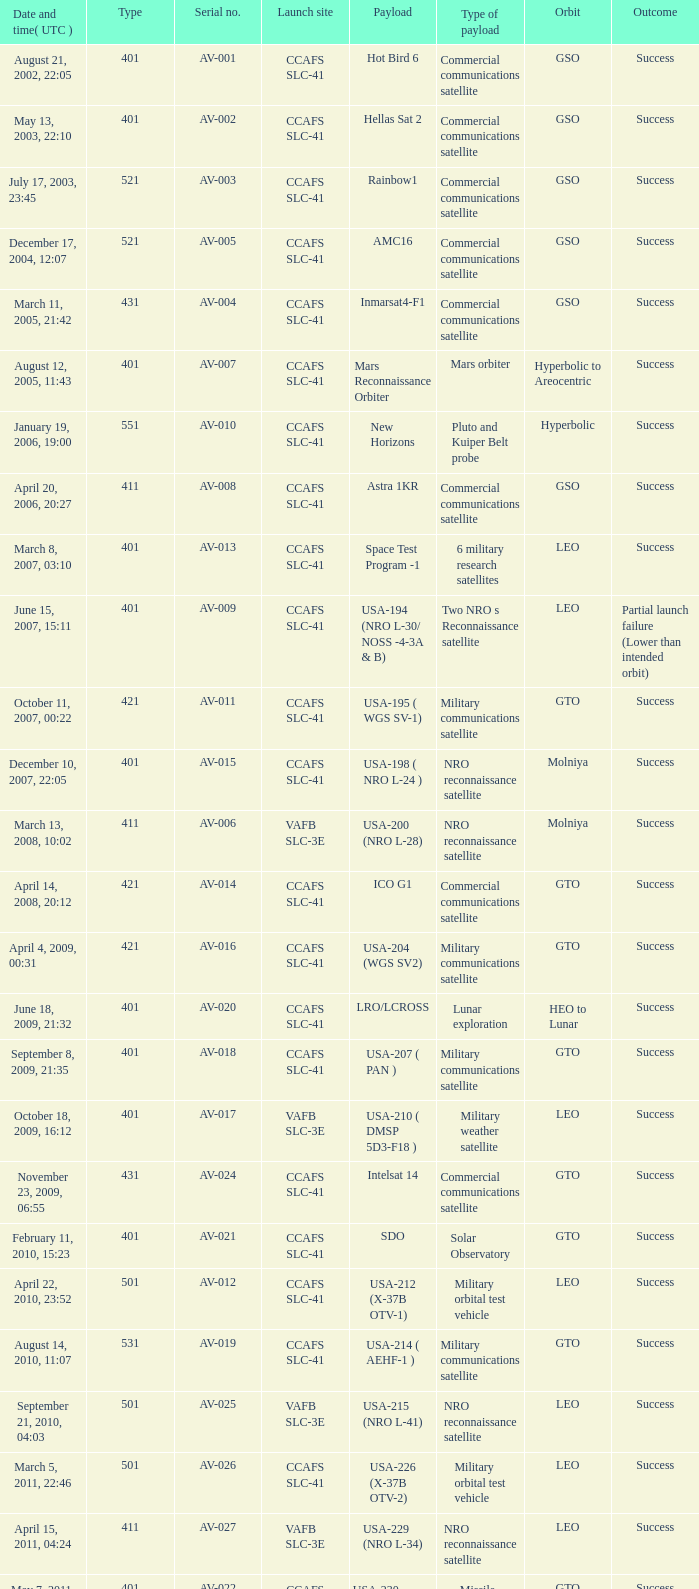What payload was on November 26, 2011, 15:02? Mars rover. 